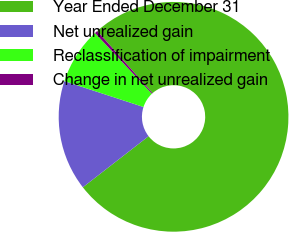Convert chart to OTSL. <chart><loc_0><loc_0><loc_500><loc_500><pie_chart><fcel>Year Ended December 31<fcel>Net unrealized gain<fcel>Reclassification of impairment<fcel>Change in net unrealized gain<nl><fcel>76.06%<fcel>15.54%<fcel>7.98%<fcel>0.42%<nl></chart> 